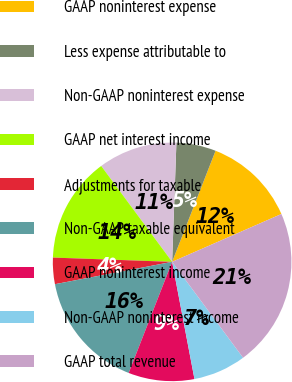Convert chart. <chart><loc_0><loc_0><loc_500><loc_500><pie_chart><fcel>GAAP noninterest expense<fcel>Less expense attributable to<fcel>Non-GAAP noninterest expense<fcel>GAAP net interest income<fcel>Adjustments for taxable<fcel>Non-GAAP taxable equivalent<fcel>GAAP noninterest income<fcel>Non-GAAP noninterest income<fcel>GAAP total revenue<nl><fcel>12.5%<fcel>5.36%<fcel>10.71%<fcel>14.29%<fcel>3.57%<fcel>16.07%<fcel>8.93%<fcel>7.14%<fcel>21.43%<nl></chart> 